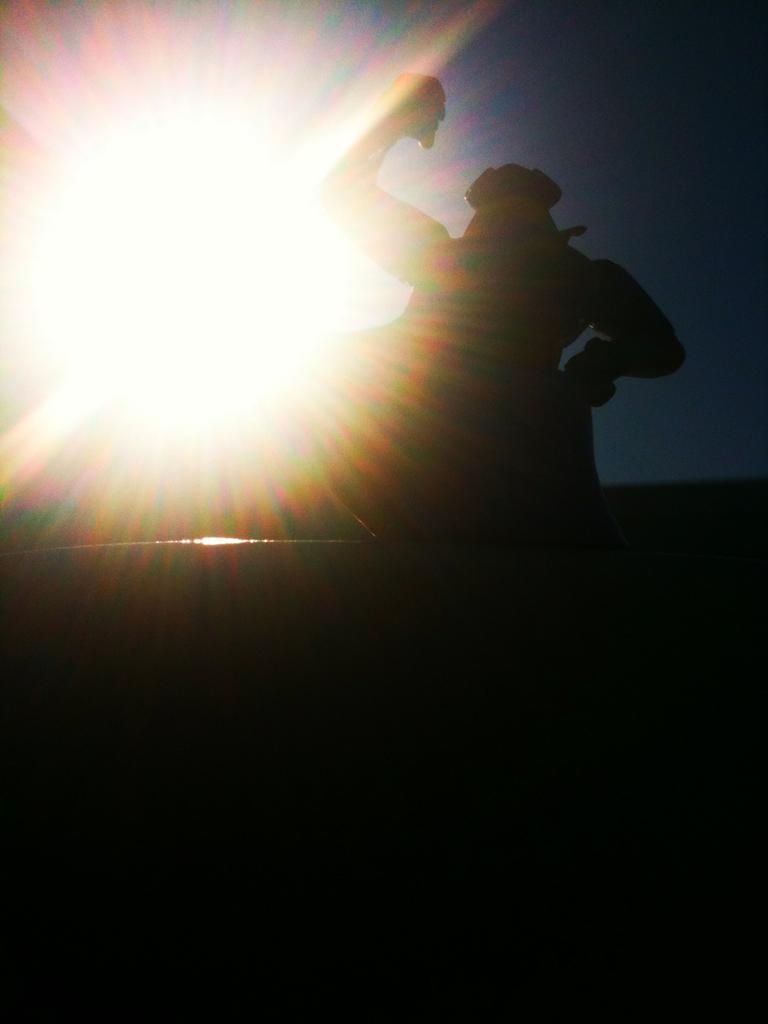In one or two sentences, can you explain what this image depicts? In the image there is a person visible on the right side and there is a bright light on the left side and above its sky. 